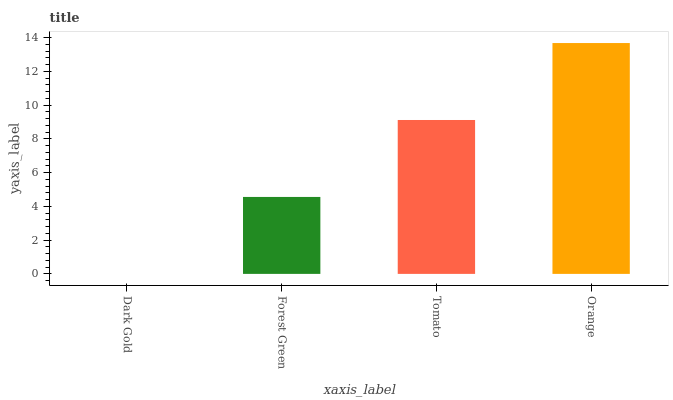Is Dark Gold the minimum?
Answer yes or no. Yes. Is Orange the maximum?
Answer yes or no. Yes. Is Forest Green the minimum?
Answer yes or no. No. Is Forest Green the maximum?
Answer yes or no. No. Is Forest Green greater than Dark Gold?
Answer yes or no. Yes. Is Dark Gold less than Forest Green?
Answer yes or no. Yes. Is Dark Gold greater than Forest Green?
Answer yes or no. No. Is Forest Green less than Dark Gold?
Answer yes or no. No. Is Tomato the high median?
Answer yes or no. Yes. Is Forest Green the low median?
Answer yes or no. Yes. Is Orange the high median?
Answer yes or no. No. Is Dark Gold the low median?
Answer yes or no. No. 